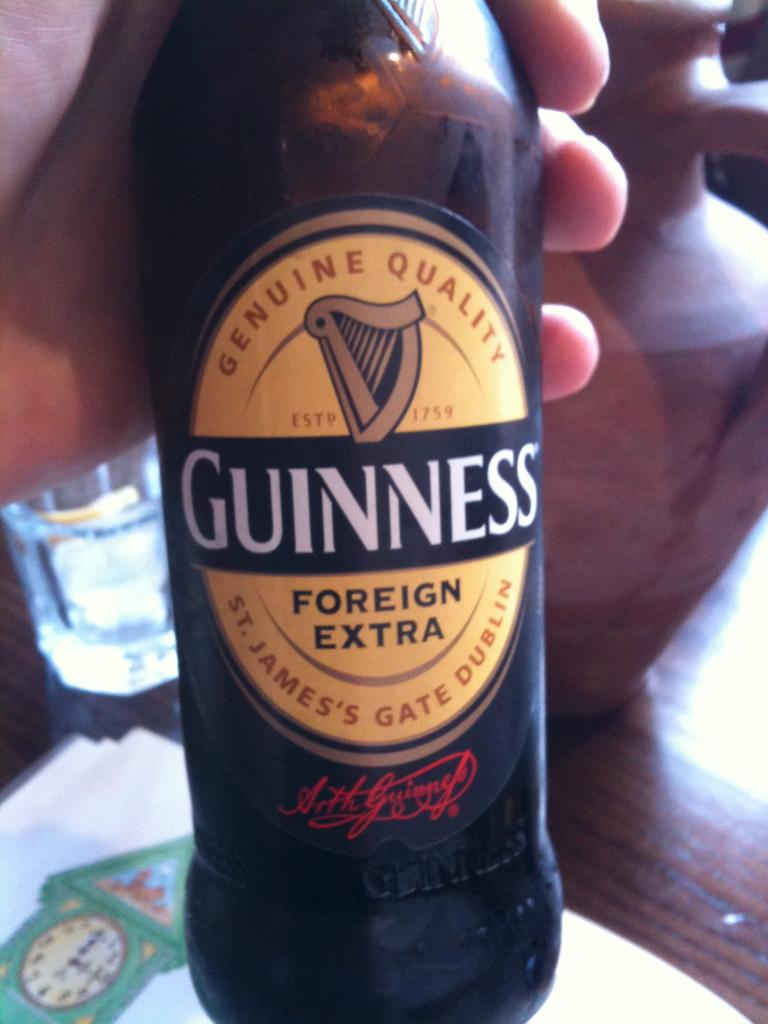<image>
Present a compact description of the photo's key features. someone is holding a bottle of Guinness foreign extra beer 